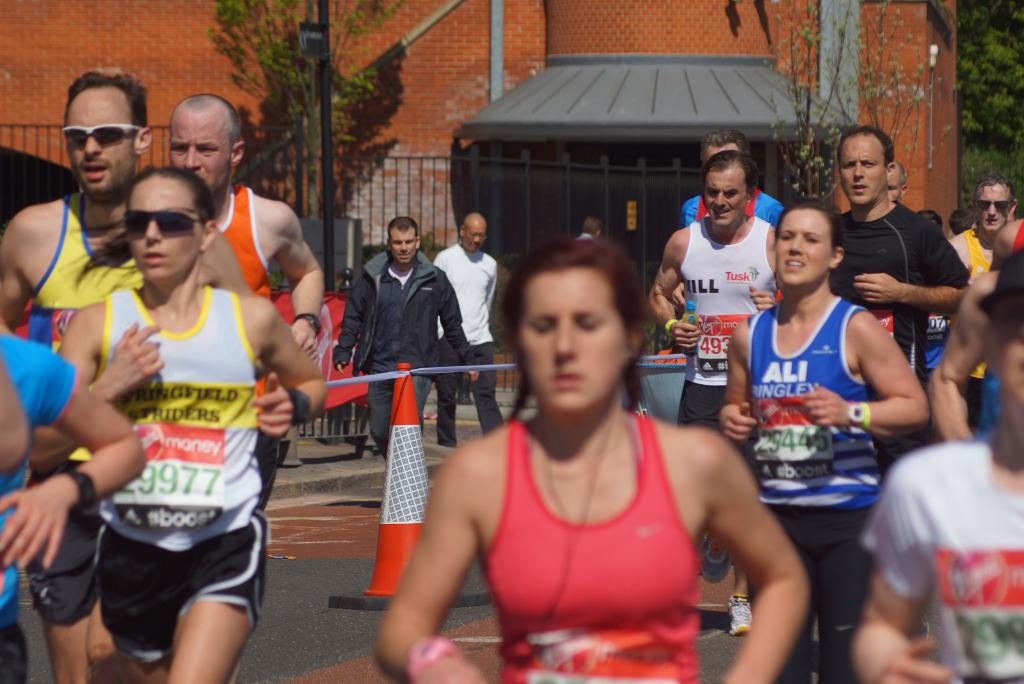Provide a one-sentence caption for the provided image. Participants of various ages and fitness levels compete in a charity marathon event, racing through an urban setting on a sunny day to raise funds and awareness for various causes. 